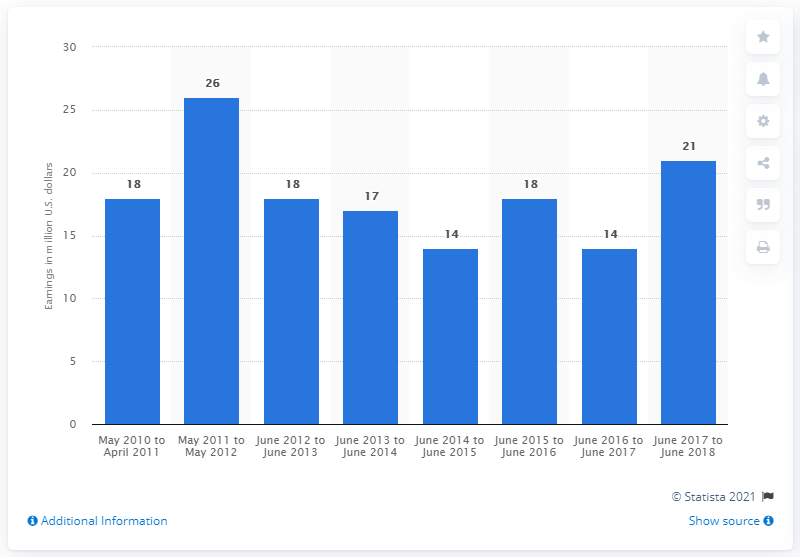Point out several critical features in this image. John Grisham's earnings from the previous year were approximately $14 million. 